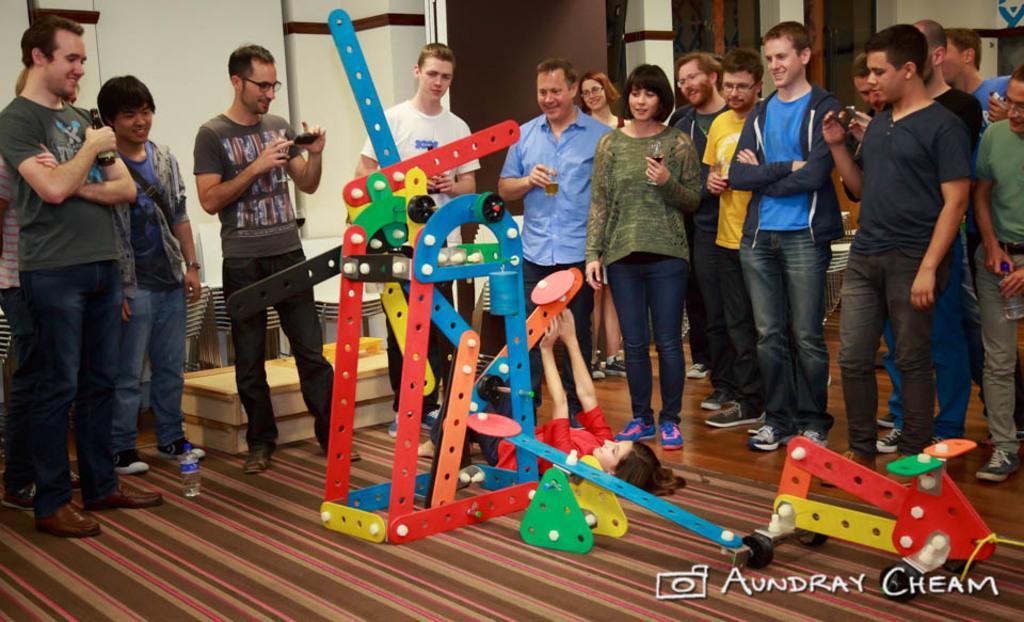Can you describe this image briefly? In this image we can see a group of people standing on the floor. In that some are holding the glasses, bottles and some devices. We can also see some toys, a bottle and a child lying on the floor. On the backside we can see a wall. 